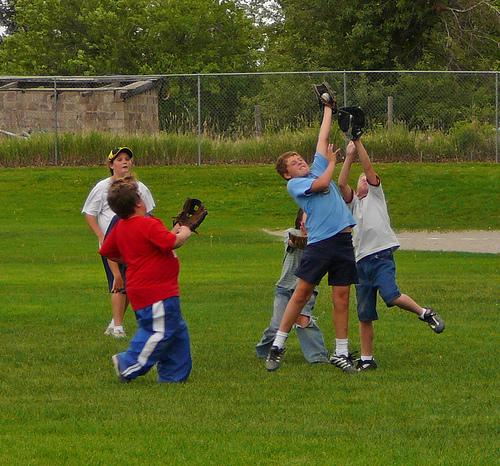What is the main action happening in this image? The main action in the image is boys playing baseball and trying to catch the ball. Identify the color of the shirt of the boy who is catching the baseball. The boy catching the baseball is wearing a blue shirt. Are there any boys wearing both blue shirt and blue shorts? If yes, how many? Yes, there is one boy wearing both a blue shirt and blue shorts. Count the number of instances of short green and brown grass in the image. There are seven instances of short green and brown grass in the image. How many boys are visible in the photo, and what are they doing? There are four boys visible in the photo; one in a red shirt, one in a white shirt, one wearing a blue shirt and shorts, and one in a gray shirt. They are playing and catching a baseball. What is the significance of the image, as mentioned in the captions? The image is significant as it will soon be published in a magazine. What is the role of Jason Zander in the context of this image? Jason Zander is mentioned to take over ownership of the photo. What types of clothing items are the boys wearing in the image? The boys are wearing various colored shirts, shorts, pants, shoes, gloves, and hats. Can you describe the landscape and vegetation visible in the image? The landscape consists of a grassy field with both short green and brown grass and long grass behind a fence. Evaluate the mood or sentiment of the image based on the activities and characters in it. The mood of the image can be described as energetic, joyful, and active, as boys are playing and engaging in a game of baseball. Which color of pants is being worn by a boy wearing a gray shirt?  Blue shorts What emotions or feelings can be associated with the image? Excitement, happiness, and determination, as the boys are engaged in a dynamic, competitive, and fun activity playing baseball. Describe the scene in the image. The image shows a group of boys playing baseball on a field with short green and brown grass, wearing different colored shirts, pants, gloves, and hats, near a fence and a dilapidated stone shed. Are there any written words or text in the image?  No, there are no written words or text in the image. Describe an interaction between two objects or people in the image. A boy is catching the baseball using his black baseball glove, demonstrating interaction and cooperation in the game. Identify the different areas of grass in the image. long grass behind the fence, short green and brown grass in various locations Is the quality of the image suitable for publication in a magazine? Yes, the quality of the image is suitable for publication in a magazine. Identify an unusual or unexpected object in the image. A dilapidated stone shed in the background is an unusual element in the image of boys playing baseball. Identify three objects belonging to a boy. red shirt, yellow and black hat, blue pants with white stripe Find and describe the object mentioned as "blue shirt of boy catching the ball." The object is a boy's blue shirt, located at coordinates X:283 Y:157, with a width of 70 and a height of 70 pixels. Describe an attribute of the boy wearing a tshirt. The boy is wearing a red tshirt. 